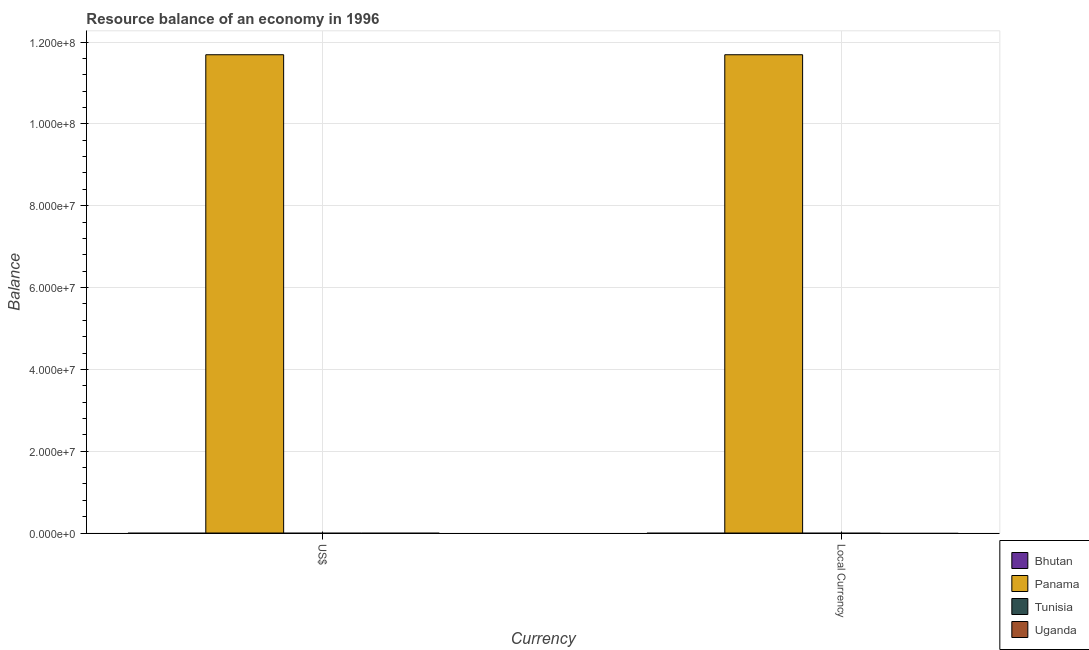Are the number of bars per tick equal to the number of legend labels?
Your response must be concise. No. Are the number of bars on each tick of the X-axis equal?
Your answer should be very brief. Yes. How many bars are there on the 1st tick from the right?
Give a very brief answer. 1. What is the label of the 1st group of bars from the left?
Your response must be concise. US$. Across all countries, what is the maximum resource balance in us$?
Offer a very short reply. 1.17e+08. In which country was the resource balance in us$ maximum?
Your answer should be very brief. Panama. What is the total resource balance in constant us$ in the graph?
Offer a very short reply. 1.17e+08. What is the difference between the resource balance in us$ in Uganda and the resource balance in constant us$ in Panama?
Provide a short and direct response. -1.17e+08. What is the average resource balance in constant us$ per country?
Offer a terse response. 2.92e+07. What is the difference between the resource balance in us$ and resource balance in constant us$ in Panama?
Provide a short and direct response. 0. In how many countries, is the resource balance in constant us$ greater than the average resource balance in constant us$ taken over all countries?
Your answer should be very brief. 1. How many bars are there?
Provide a short and direct response. 2. Are all the bars in the graph horizontal?
Your answer should be very brief. No. What is the difference between two consecutive major ticks on the Y-axis?
Provide a succinct answer. 2.00e+07. Are the values on the major ticks of Y-axis written in scientific E-notation?
Offer a terse response. Yes. Does the graph contain any zero values?
Make the answer very short. Yes. Where does the legend appear in the graph?
Provide a succinct answer. Bottom right. How are the legend labels stacked?
Give a very brief answer. Vertical. What is the title of the graph?
Your answer should be compact. Resource balance of an economy in 1996. Does "Mauritius" appear as one of the legend labels in the graph?
Offer a terse response. No. What is the label or title of the X-axis?
Your response must be concise. Currency. What is the label or title of the Y-axis?
Your response must be concise. Balance. What is the Balance of Panama in US$?
Your answer should be compact. 1.17e+08. What is the Balance in Bhutan in Local Currency?
Your response must be concise. 0. What is the Balance in Panama in Local Currency?
Your answer should be compact. 1.17e+08. Across all Currency, what is the maximum Balance in Panama?
Provide a short and direct response. 1.17e+08. Across all Currency, what is the minimum Balance of Panama?
Your answer should be very brief. 1.17e+08. What is the total Balance of Bhutan in the graph?
Your answer should be compact. 0. What is the total Balance in Panama in the graph?
Make the answer very short. 2.34e+08. What is the total Balance in Tunisia in the graph?
Ensure brevity in your answer.  0. What is the total Balance in Uganda in the graph?
Offer a terse response. 0. What is the average Balance of Bhutan per Currency?
Make the answer very short. 0. What is the average Balance in Panama per Currency?
Ensure brevity in your answer.  1.17e+08. What is the average Balance of Uganda per Currency?
Make the answer very short. 0. What is the ratio of the Balance in Panama in US$ to that in Local Currency?
Your response must be concise. 1. What is the difference between the highest and the second highest Balance in Panama?
Your answer should be very brief. 0. What is the difference between the highest and the lowest Balance of Panama?
Give a very brief answer. 0. 